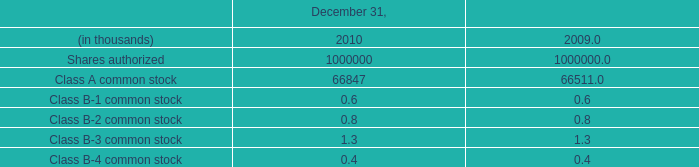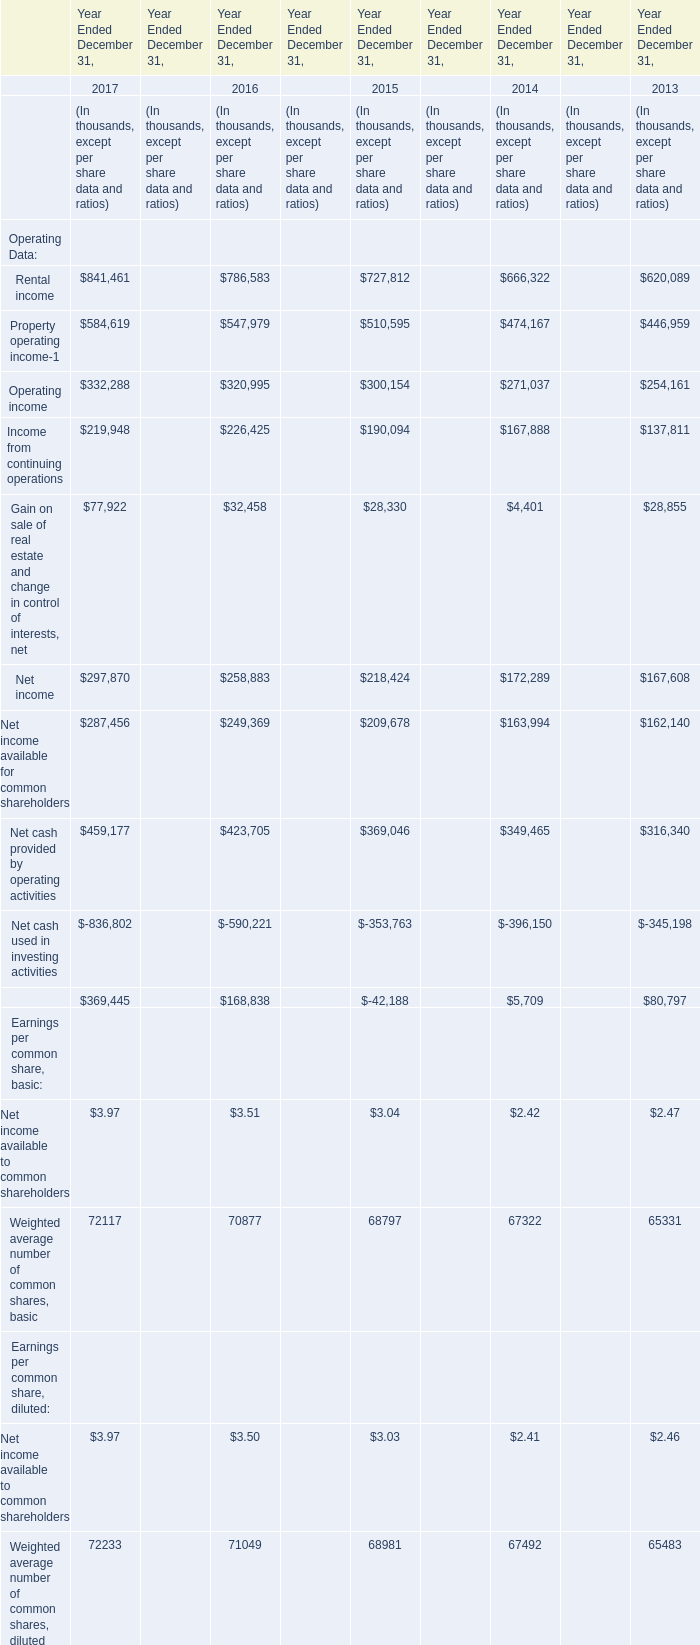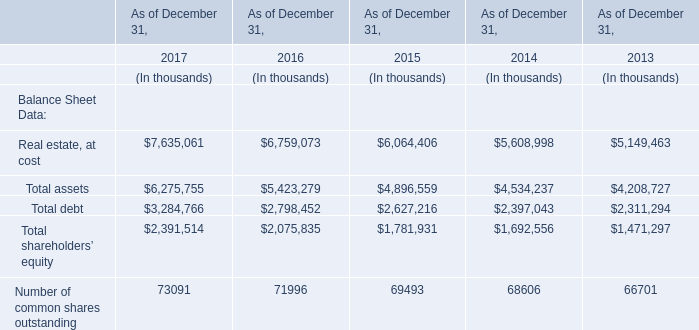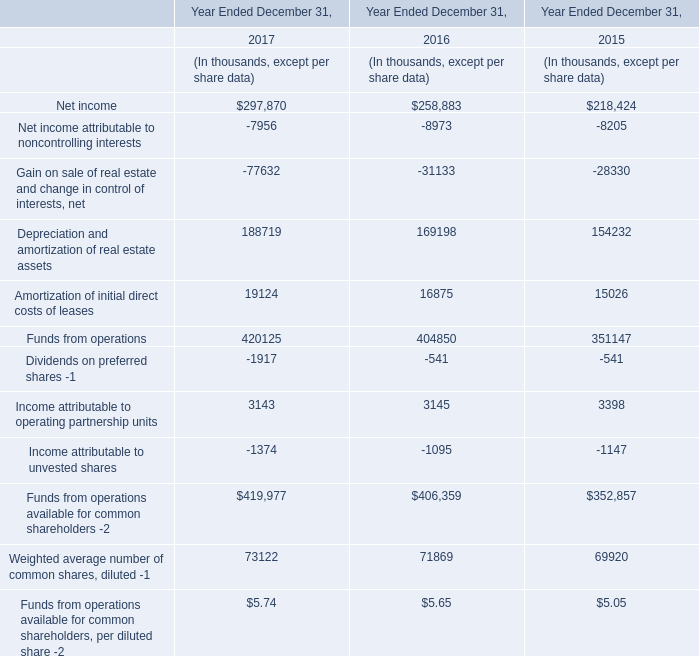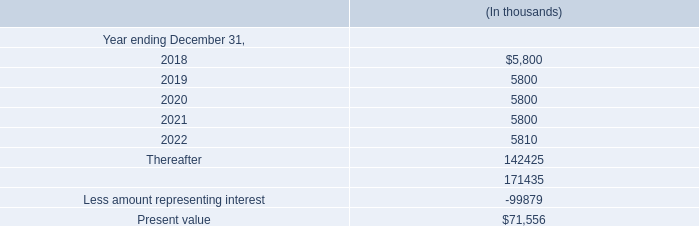Which year is the value of Total assets the highest? 
Answer: 2017. 